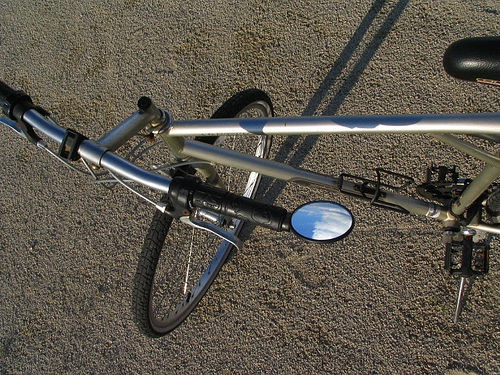Describe the objects in this image and their specific colors. I can see a bicycle in gray, black, and darkgray tones in this image. 